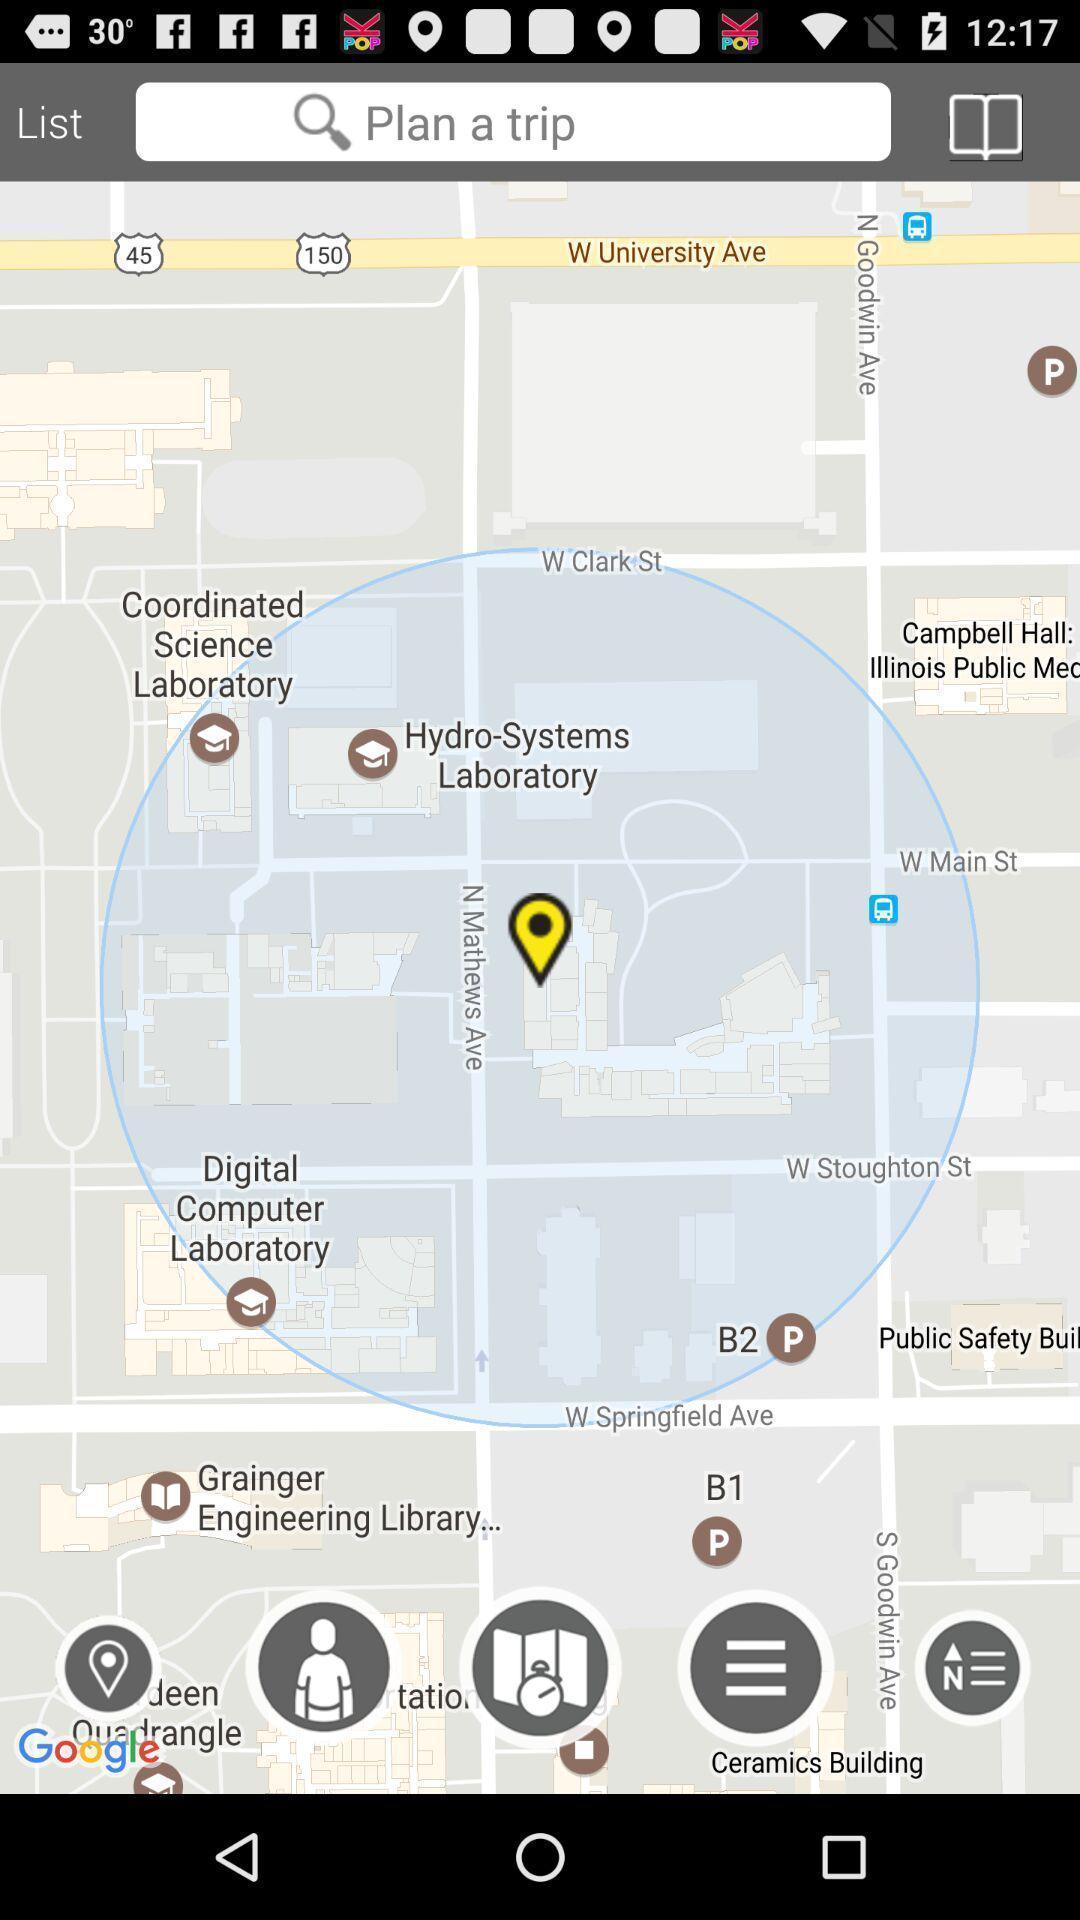What details can you identify in this image? Page showing the current location along with multiple options. 